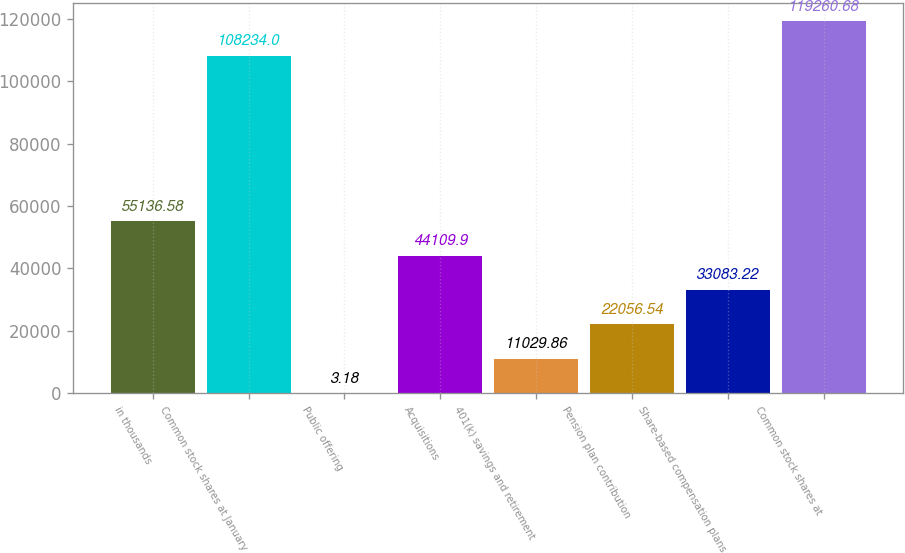Convert chart to OTSL. <chart><loc_0><loc_0><loc_500><loc_500><bar_chart><fcel>in thousands<fcel>Common stock shares at January<fcel>Public offering<fcel>Acquisitions<fcel>401(k) savings and retirement<fcel>Pension plan contribution<fcel>Share-based compensation plans<fcel>Common stock shares at<nl><fcel>55136.6<fcel>108234<fcel>3.18<fcel>44109.9<fcel>11029.9<fcel>22056.5<fcel>33083.2<fcel>119261<nl></chart> 